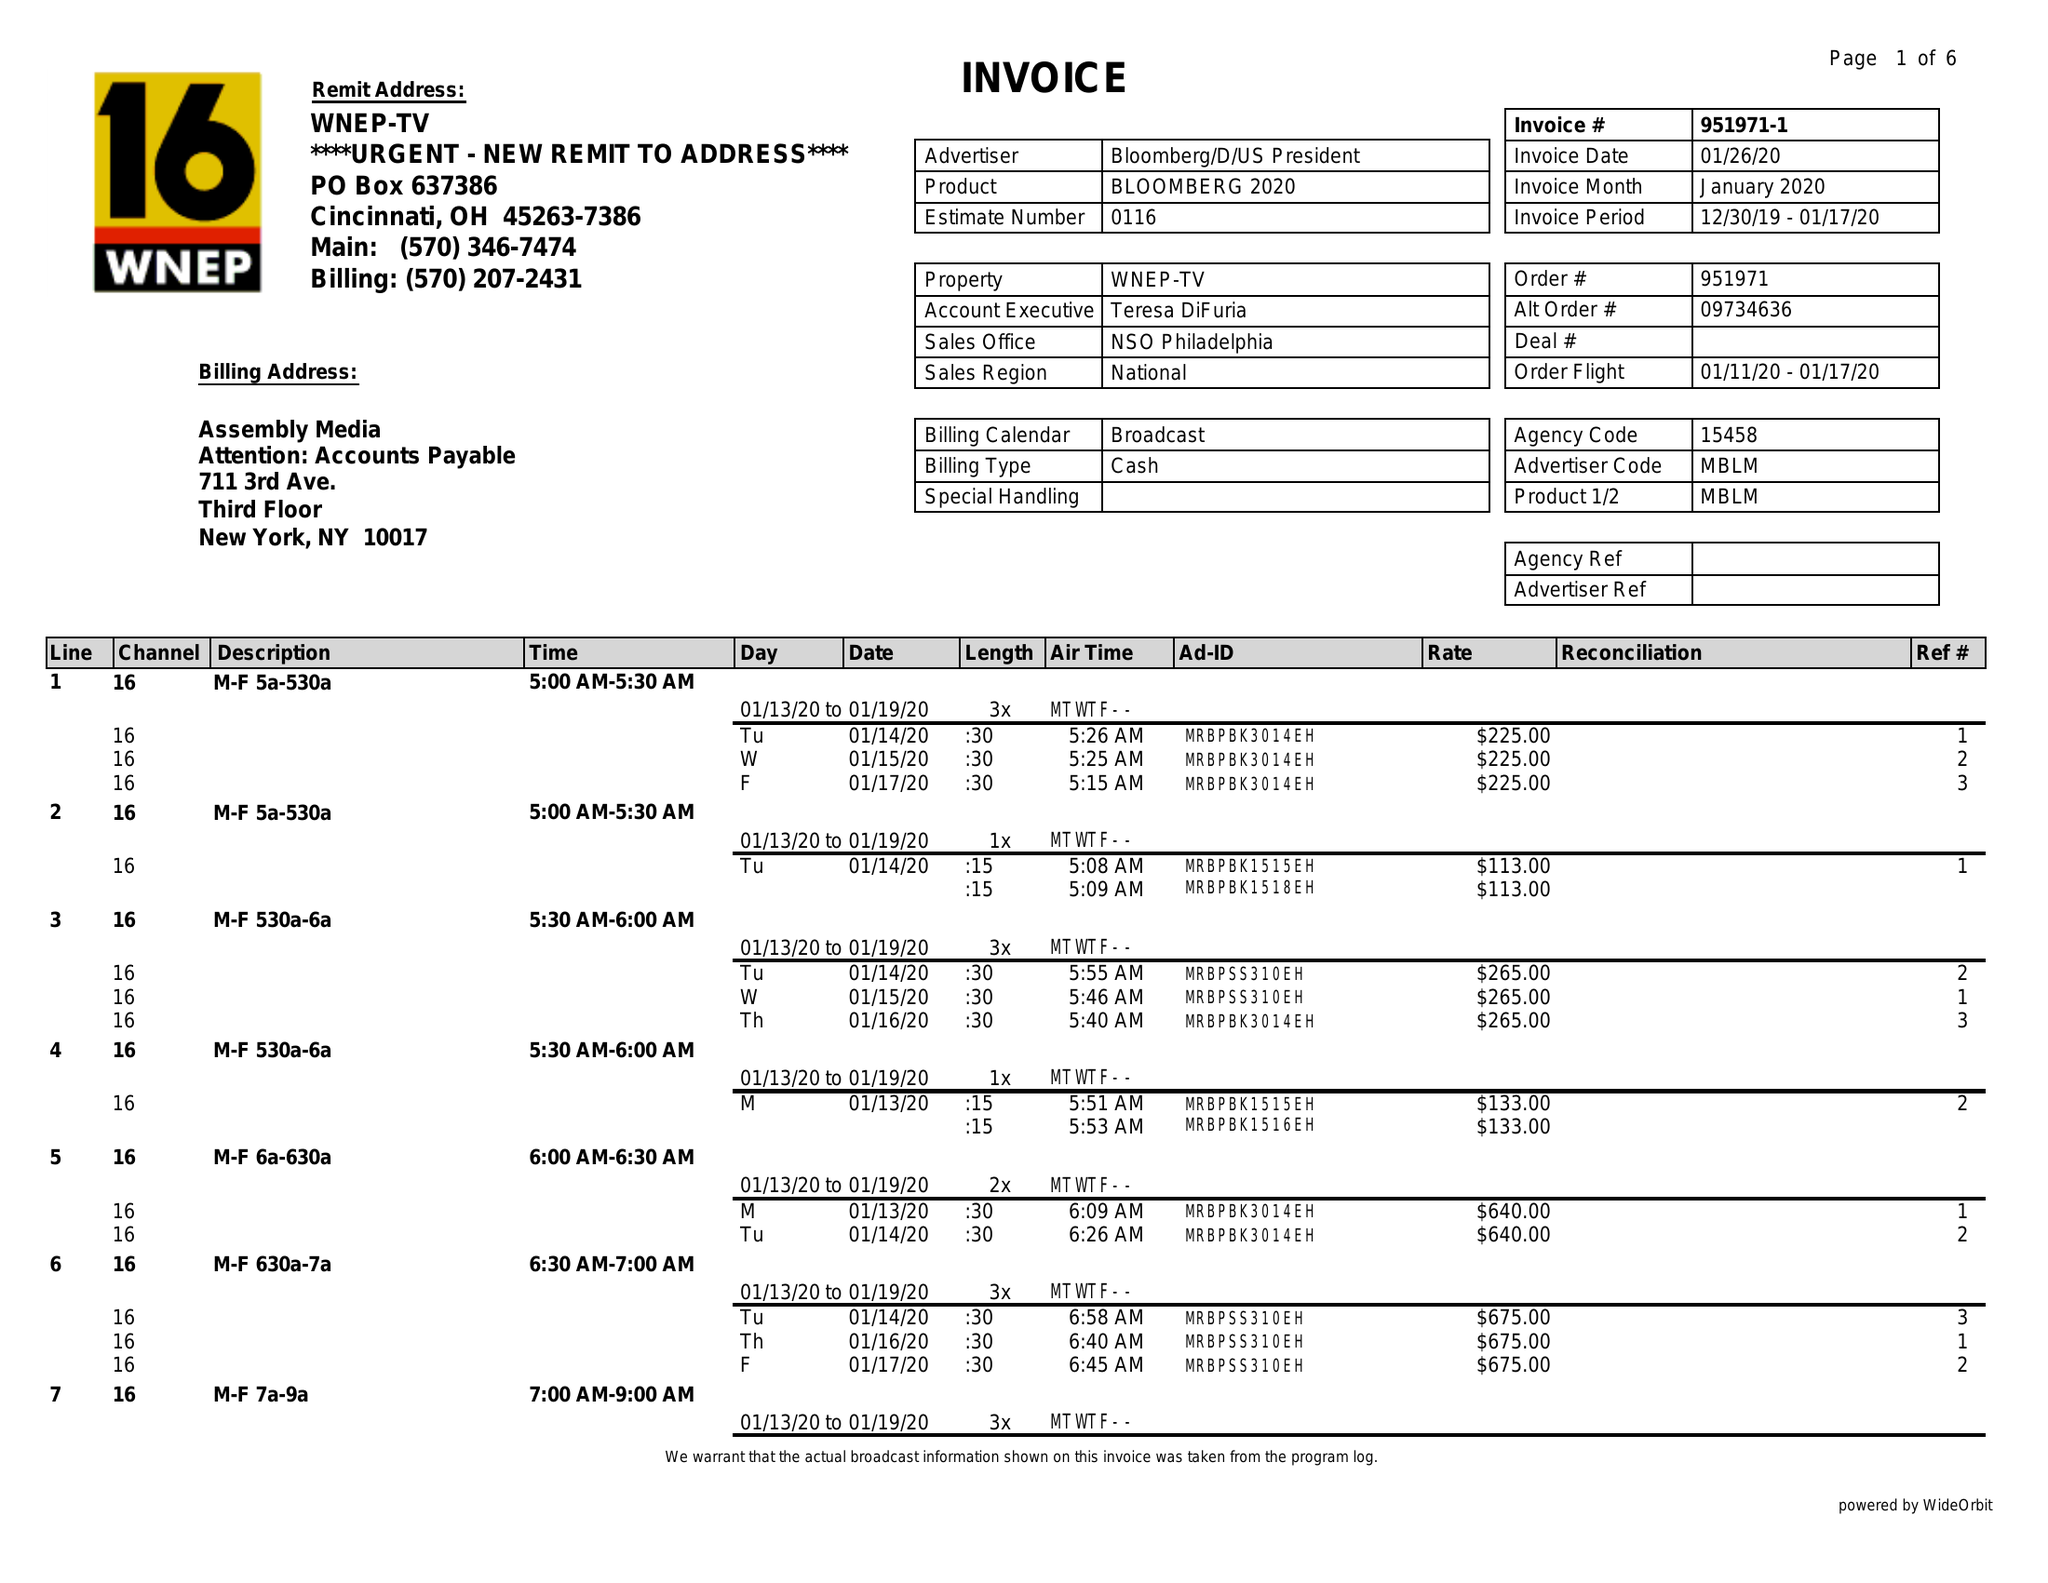What is the value for the flight_from?
Answer the question using a single word or phrase. 01/11/20 